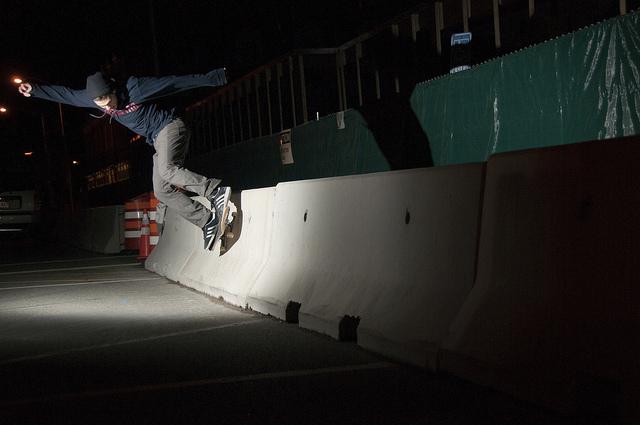What time of day is it?
Keep it brief. Night. Is this a skateboarding park?
Be succinct. No. How is the guy on the skateboard?
Answer briefly. Good. What is on the walls of the ramp?
Answer briefly. Light. 